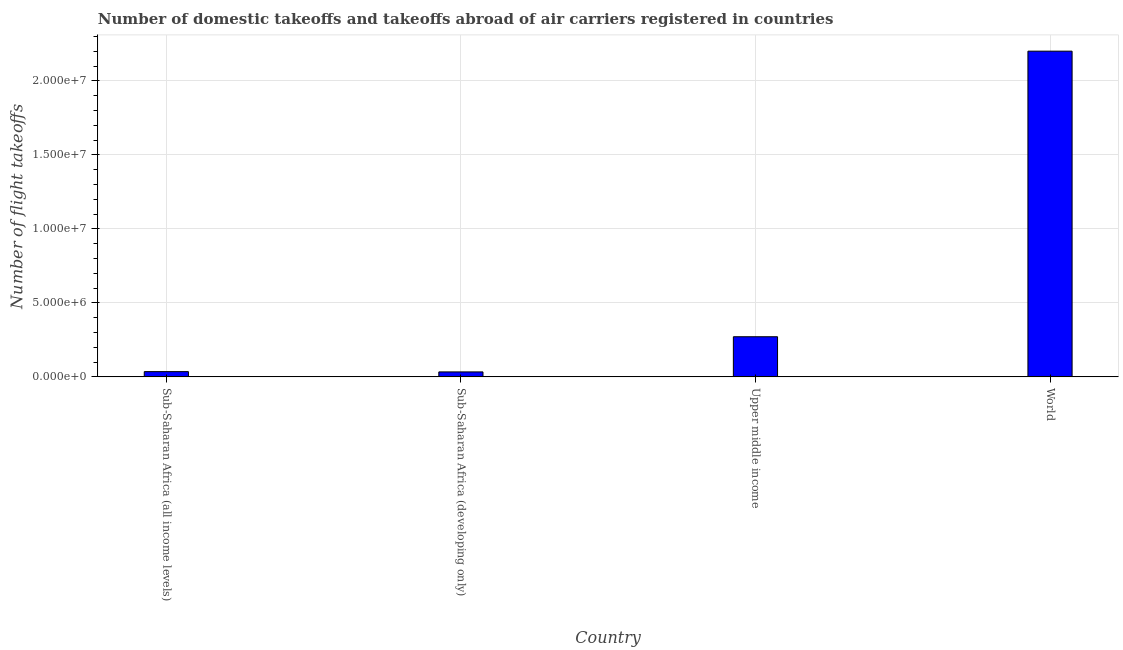Does the graph contain any zero values?
Provide a succinct answer. No. What is the title of the graph?
Give a very brief answer. Number of domestic takeoffs and takeoffs abroad of air carriers registered in countries. What is the label or title of the X-axis?
Offer a terse response. Country. What is the label or title of the Y-axis?
Offer a very short reply. Number of flight takeoffs. What is the number of flight takeoffs in World?
Keep it short and to the point. 2.20e+07. Across all countries, what is the maximum number of flight takeoffs?
Your answer should be compact. 2.20e+07. Across all countries, what is the minimum number of flight takeoffs?
Offer a very short reply. 3.35e+05. In which country was the number of flight takeoffs maximum?
Your answer should be compact. World. In which country was the number of flight takeoffs minimum?
Keep it short and to the point. Sub-Saharan Africa (developing only). What is the sum of the number of flight takeoffs?
Give a very brief answer. 2.54e+07. What is the difference between the number of flight takeoffs in Sub-Saharan Africa (developing only) and World?
Make the answer very short. -2.17e+07. What is the average number of flight takeoffs per country?
Your answer should be compact. 6.35e+06. What is the median number of flight takeoffs?
Offer a terse response. 1.53e+06. What is the ratio of the number of flight takeoffs in Sub-Saharan Africa (all income levels) to that in World?
Give a very brief answer. 0.02. What is the difference between the highest and the second highest number of flight takeoffs?
Your response must be concise. 1.93e+07. What is the difference between the highest and the lowest number of flight takeoffs?
Give a very brief answer. 2.17e+07. In how many countries, is the number of flight takeoffs greater than the average number of flight takeoffs taken over all countries?
Your answer should be compact. 1. Are all the bars in the graph horizontal?
Give a very brief answer. No. Are the values on the major ticks of Y-axis written in scientific E-notation?
Ensure brevity in your answer.  Yes. What is the Number of flight takeoffs in Sub-Saharan Africa (all income levels)?
Offer a terse response. 3.54e+05. What is the Number of flight takeoffs of Sub-Saharan Africa (developing only)?
Keep it short and to the point. 3.35e+05. What is the Number of flight takeoffs in Upper middle income?
Ensure brevity in your answer.  2.71e+06. What is the Number of flight takeoffs in World?
Ensure brevity in your answer.  2.20e+07. What is the difference between the Number of flight takeoffs in Sub-Saharan Africa (all income levels) and Sub-Saharan Africa (developing only)?
Offer a terse response. 1.90e+04. What is the difference between the Number of flight takeoffs in Sub-Saharan Africa (all income levels) and Upper middle income?
Your answer should be compact. -2.36e+06. What is the difference between the Number of flight takeoffs in Sub-Saharan Africa (all income levels) and World?
Your answer should be compact. -2.17e+07. What is the difference between the Number of flight takeoffs in Sub-Saharan Africa (developing only) and Upper middle income?
Keep it short and to the point. -2.38e+06. What is the difference between the Number of flight takeoffs in Sub-Saharan Africa (developing only) and World?
Your answer should be compact. -2.17e+07. What is the difference between the Number of flight takeoffs in Upper middle income and World?
Give a very brief answer. -1.93e+07. What is the ratio of the Number of flight takeoffs in Sub-Saharan Africa (all income levels) to that in Sub-Saharan Africa (developing only)?
Your answer should be very brief. 1.06. What is the ratio of the Number of flight takeoffs in Sub-Saharan Africa (all income levels) to that in Upper middle income?
Your answer should be compact. 0.13. What is the ratio of the Number of flight takeoffs in Sub-Saharan Africa (all income levels) to that in World?
Your answer should be compact. 0.02. What is the ratio of the Number of flight takeoffs in Sub-Saharan Africa (developing only) to that in Upper middle income?
Offer a terse response. 0.12. What is the ratio of the Number of flight takeoffs in Sub-Saharan Africa (developing only) to that in World?
Your answer should be compact. 0.01. What is the ratio of the Number of flight takeoffs in Upper middle income to that in World?
Offer a terse response. 0.12. 